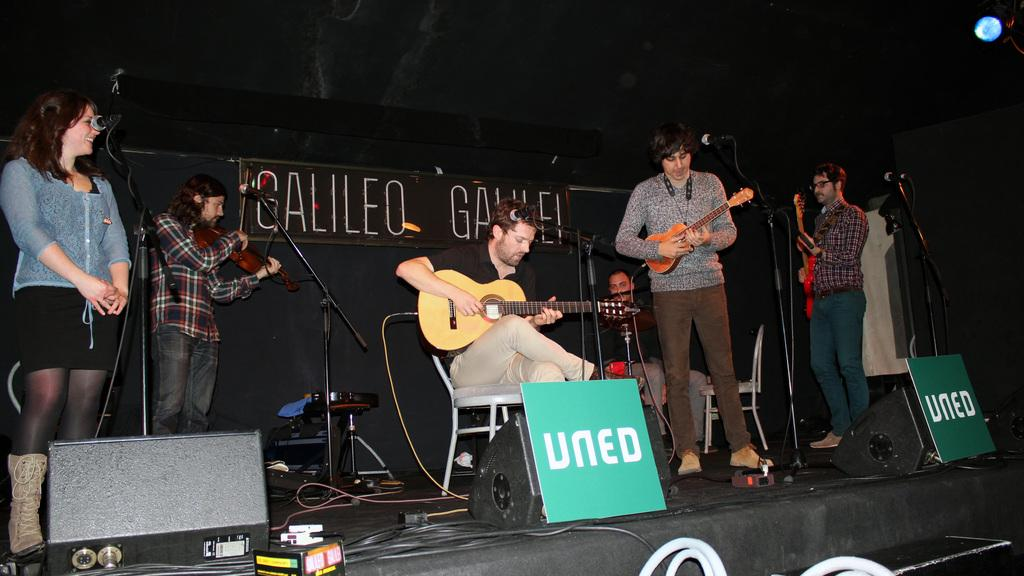What are the people in the image doing? The people in the image are playing instruments. Where are the people playing instruments located? They are on a dais. What is the woman in the image doing? The woman is singing. How is the woman singing in the image? She is using a microphone. What type of rest can be seen being exchanged between the people playing instruments in the image? There is no rest being exchanged between the people playing instruments in the image; they are actively playing their instruments. 